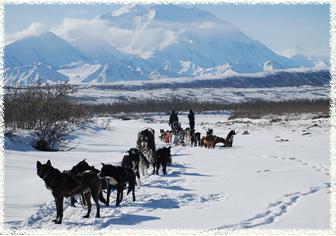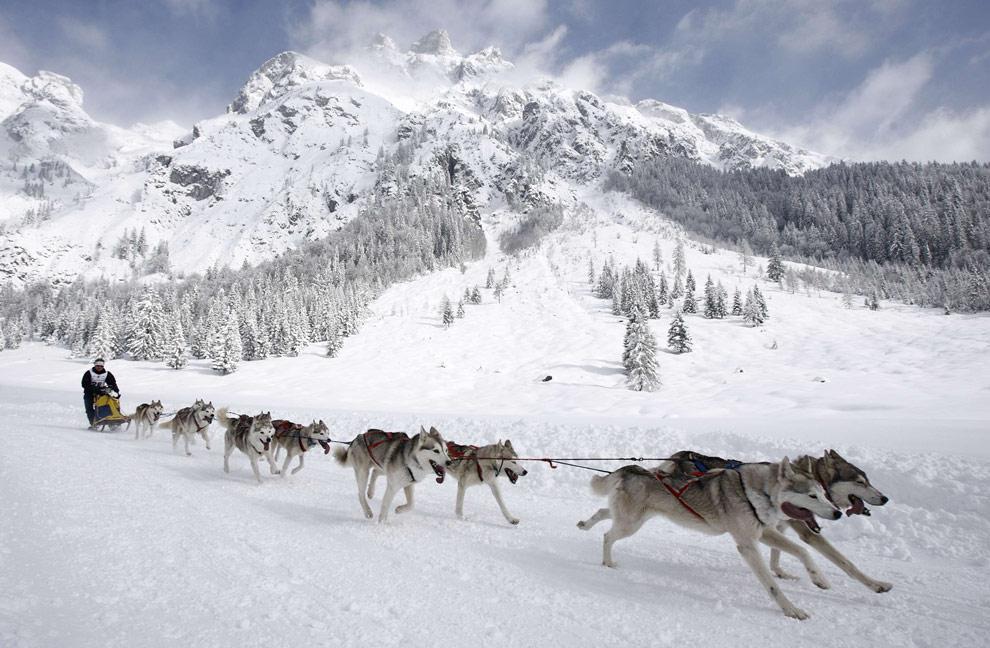The first image is the image on the left, the second image is the image on the right. For the images shown, is this caption "There is a person in a red coat in the image on the right." true? Answer yes or no. No. 